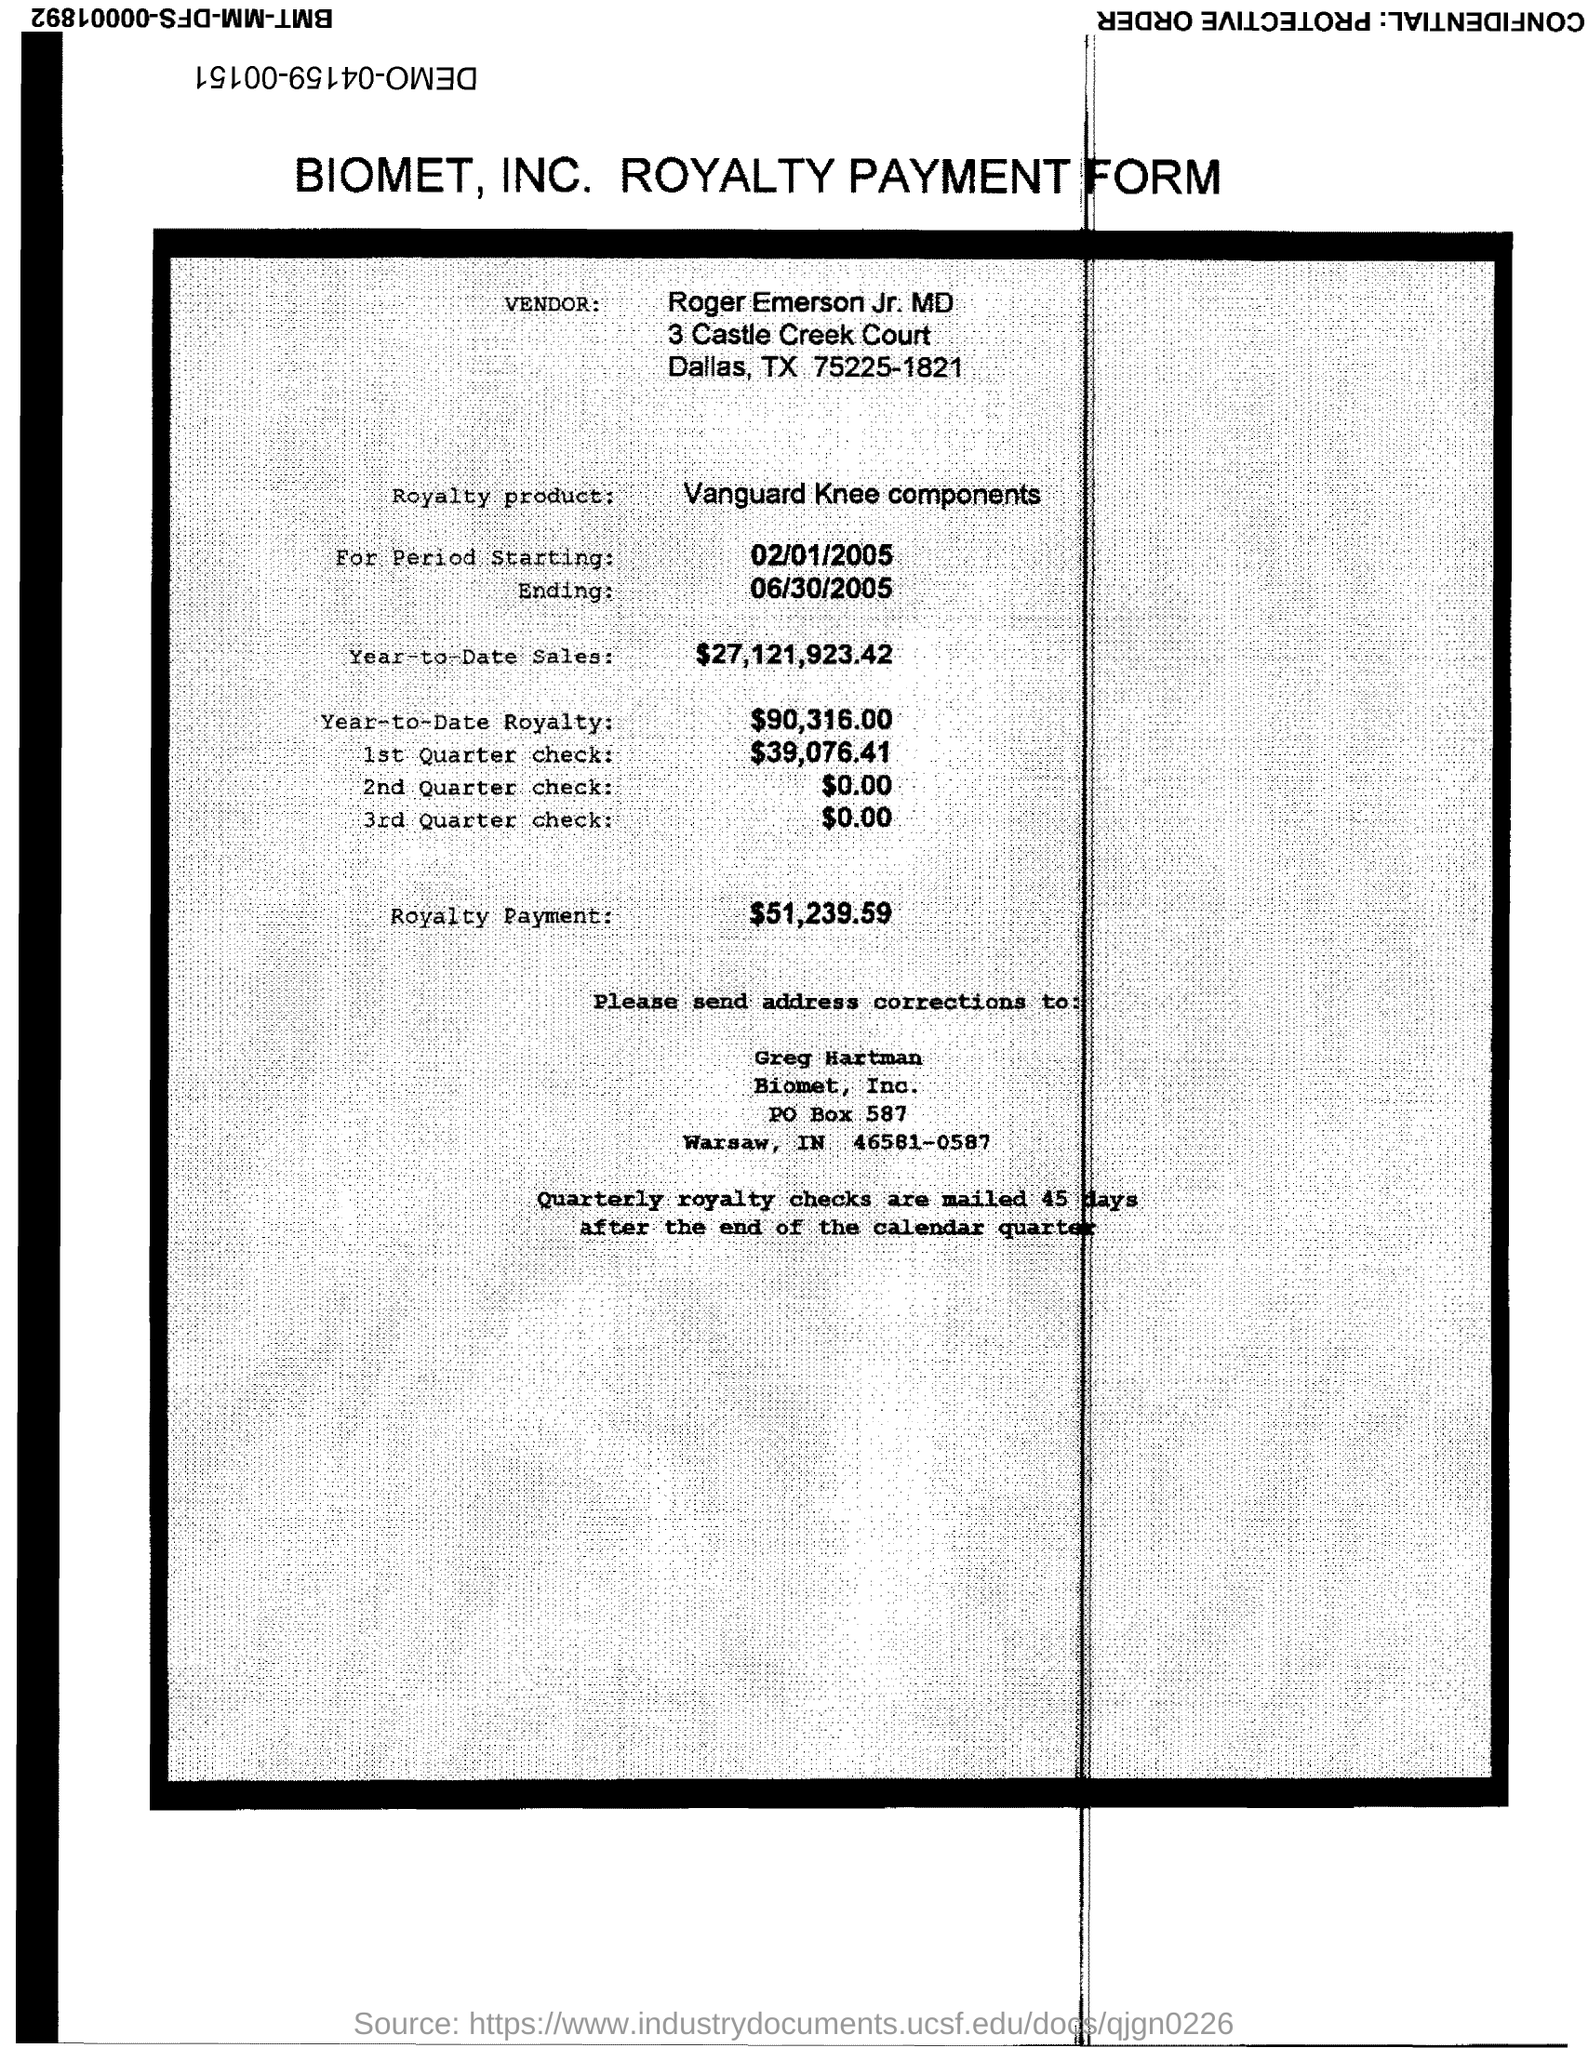Who is the vendor mentioned in the form?
Your response must be concise. Roger Emerson Jr. MD. What is the royalty product given in the form?
Your response must be concise. Vanguard Knee components. What is the Year-to-Date Sales of the royalty product?
Keep it short and to the point. $27,121,923.42. What is the start date of the royalty period?
Provide a succinct answer. 02/01/2005. What is the Year-to-Date royalty of the product?
Provide a short and direct response. $90,316.00. What is the amount of 1st quarter check mentioned in the form?
Provide a short and direct response. $39,076.41. What is the end date of the royalty period?
Your response must be concise. 06/30/2005. What is the royalty payment of the product mentioned in the form?
Keep it short and to the point. $51,239.59. What is the amount of 2nd quarter check mentioned in the form?
Make the answer very short. $0.00. 